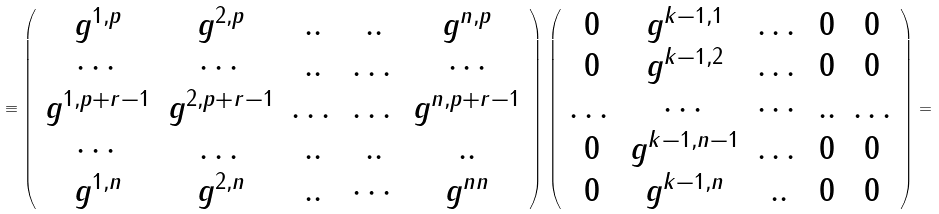<formula> <loc_0><loc_0><loc_500><loc_500>\equiv \left ( \begin{array} { c c c c c } g ^ { 1 , p } & g ^ { 2 , p } & . . & . . & g ^ { n , p } \\ \cdots & \cdots & . . & \dots & \cdots \\ g ^ { 1 , p + r - 1 } & g ^ { 2 , p + r - 1 } & \dots & \dots & g ^ { n , p + r - 1 } \\ \cdots & \dots & . . & . . & . . \\ g ^ { 1 , n } & g ^ { 2 , n } & . . & \cdots & g ^ { n n } \end{array} \right ) \left ( \begin{array} { c c c c c } 0 & g ^ { k - 1 , 1 } & \dots & 0 & 0 \\ 0 & g ^ { k - 1 , 2 } & \dots & 0 & 0 \\ \dots & \cdots & \cdots & . . & \dots \\ 0 & g ^ { k - 1 , n - 1 } & \dots & 0 & 0 \\ 0 & g ^ { k - 1 , n } & . . & 0 & 0 \end{array} \right ) =</formula> 